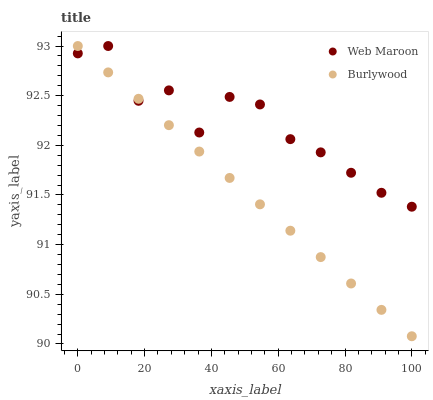Does Burlywood have the minimum area under the curve?
Answer yes or no. Yes. Does Web Maroon have the maximum area under the curve?
Answer yes or no. Yes. Does Web Maroon have the minimum area under the curve?
Answer yes or no. No. Is Burlywood the smoothest?
Answer yes or no. Yes. Is Web Maroon the roughest?
Answer yes or no. Yes. Is Web Maroon the smoothest?
Answer yes or no. No. Does Burlywood have the lowest value?
Answer yes or no. Yes. Does Web Maroon have the lowest value?
Answer yes or no. No. Does Web Maroon have the highest value?
Answer yes or no. Yes. Does Burlywood intersect Web Maroon?
Answer yes or no. Yes. Is Burlywood less than Web Maroon?
Answer yes or no. No. Is Burlywood greater than Web Maroon?
Answer yes or no. No. 